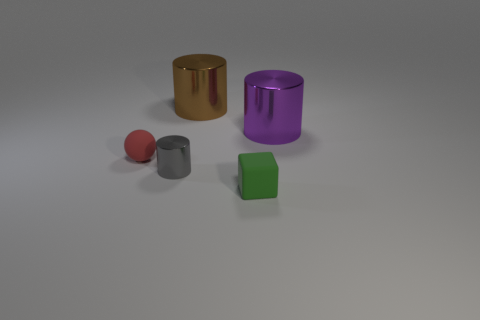Add 3 big objects. How many objects exist? 8 Subtract all gray cylinders. How many cylinders are left? 2 Subtract 0 green cylinders. How many objects are left? 5 Subtract all cylinders. How many objects are left? 2 Subtract 1 cubes. How many cubes are left? 0 Subtract all blue balls. Subtract all brown cylinders. How many balls are left? 1 Subtract all cyan balls. How many brown cylinders are left? 1 Subtract all tiny red matte things. Subtract all tiny green cubes. How many objects are left? 3 Add 2 small matte blocks. How many small matte blocks are left? 3 Add 5 small cyan matte objects. How many small cyan matte objects exist? 5 